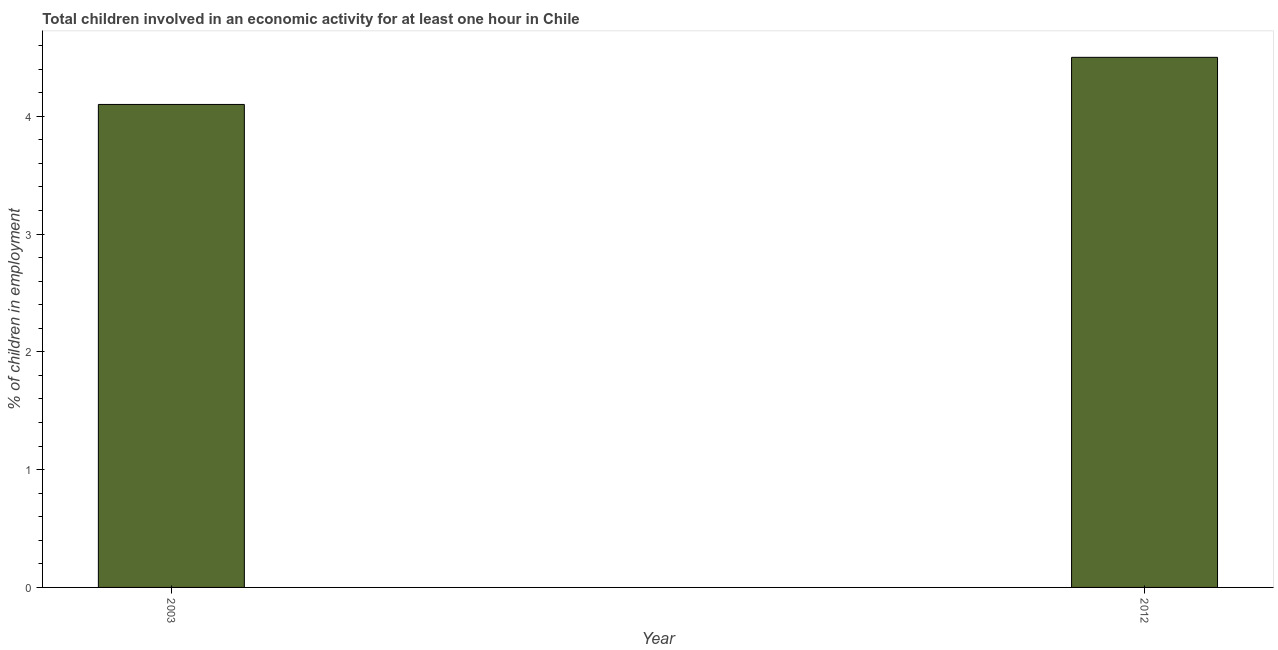What is the title of the graph?
Your response must be concise. Total children involved in an economic activity for at least one hour in Chile. What is the label or title of the X-axis?
Keep it short and to the point. Year. What is the label or title of the Y-axis?
Your response must be concise. % of children in employment. In which year was the percentage of children in employment minimum?
Offer a very short reply. 2003. What is the median percentage of children in employment?
Your answer should be compact. 4.3. Do a majority of the years between 2003 and 2012 (inclusive) have percentage of children in employment greater than 1.2 %?
Ensure brevity in your answer.  Yes. What is the ratio of the percentage of children in employment in 2003 to that in 2012?
Offer a very short reply. 0.91. Is the percentage of children in employment in 2003 less than that in 2012?
Offer a very short reply. Yes. Are all the bars in the graph horizontal?
Make the answer very short. No. What is the difference between two consecutive major ticks on the Y-axis?
Ensure brevity in your answer.  1. Are the values on the major ticks of Y-axis written in scientific E-notation?
Offer a very short reply. No. What is the % of children in employment of 2003?
Offer a very short reply. 4.1. What is the ratio of the % of children in employment in 2003 to that in 2012?
Keep it short and to the point. 0.91. 